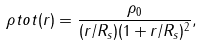<formula> <loc_0><loc_0><loc_500><loc_500>\rho t o t ( r ) = \frac { \rho _ { 0 } } { ( r / R _ { s } ) ( 1 + r / R _ { s } ) ^ { 2 } } ,</formula> 